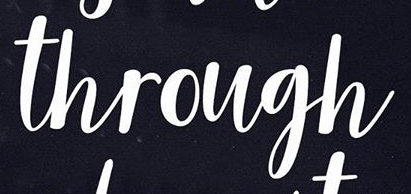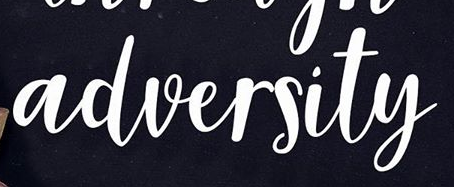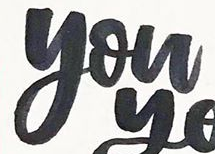What text appears in these images from left to right, separated by a semicolon? through; adversity; you 